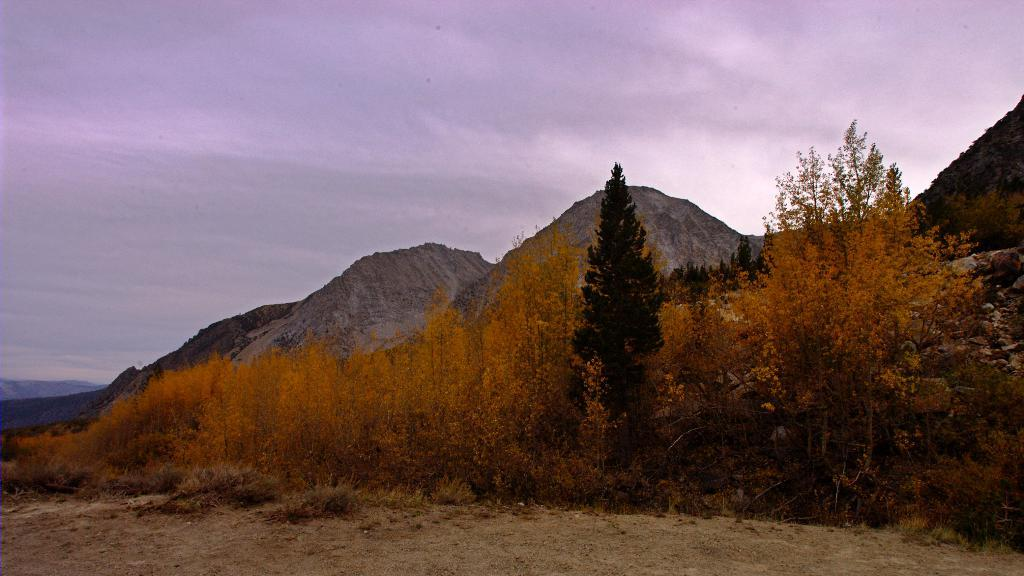What type of landscape is depicted in the image? The image features hills. What other natural elements can be seen in the image? There are trees in the image. How would you describe the weather in the image? The sky is cloudy in the image. What type of vessel can be seen in the image? There is no vessel present in the image; it features hills and trees. Can you tell me which animals are visible in the zoo in the image? There is no zoo present in the image; it features a natural landscape with hills and trees. 